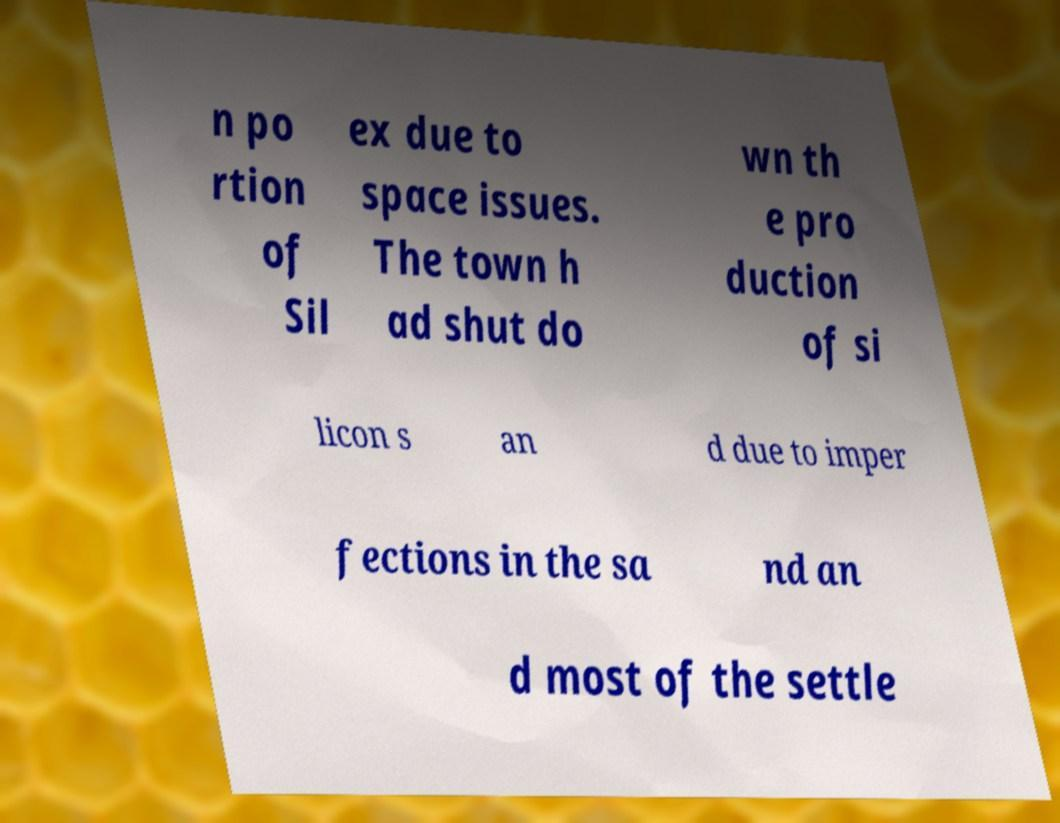There's text embedded in this image that I need extracted. Can you transcribe it verbatim? n po rtion of Sil ex due to space issues. The town h ad shut do wn th e pro duction of si licon s an d due to imper fections in the sa nd an d most of the settle 